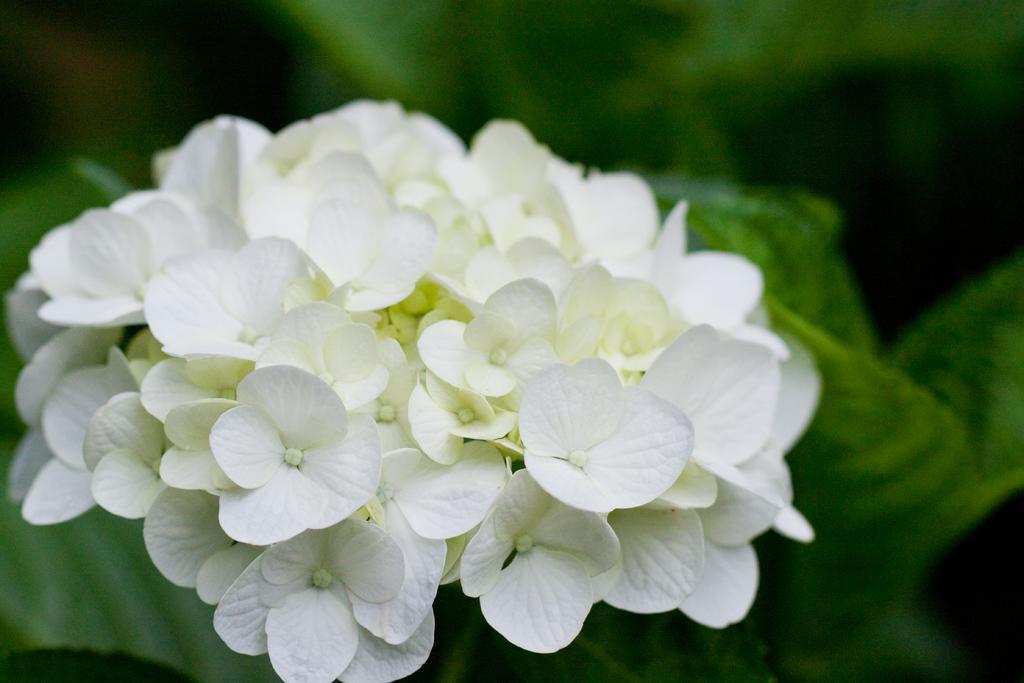Please provide a concise description of this image. There are white color flowers present in the middle of this image. We can see greenery in the background. 